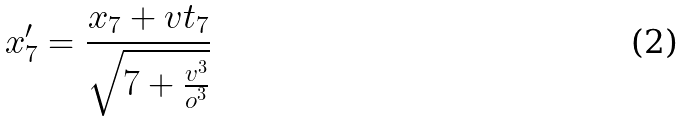<formula> <loc_0><loc_0><loc_500><loc_500>x _ { 7 } ^ { \prime } = \frac { x _ { 7 } + v t _ { 7 } } { \sqrt { 7 + \frac { v ^ { 3 } } { o ^ { 3 } } } }</formula> 